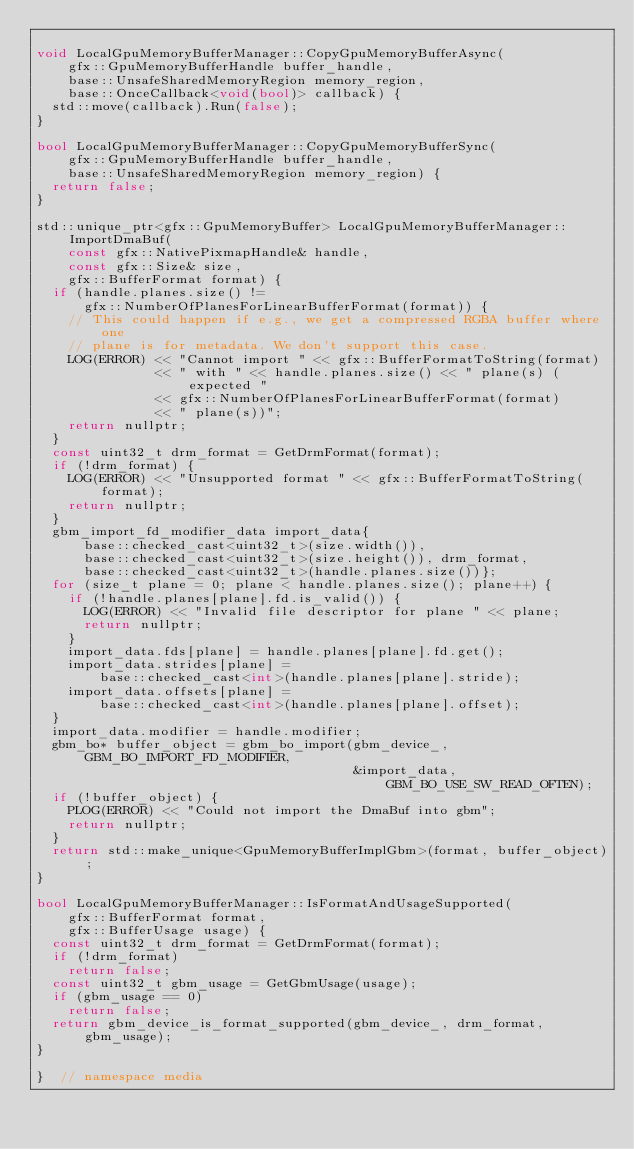<code> <loc_0><loc_0><loc_500><loc_500><_C++_>
void LocalGpuMemoryBufferManager::CopyGpuMemoryBufferAsync(
    gfx::GpuMemoryBufferHandle buffer_handle,
    base::UnsafeSharedMemoryRegion memory_region,
    base::OnceCallback<void(bool)> callback) {
  std::move(callback).Run(false);
}

bool LocalGpuMemoryBufferManager::CopyGpuMemoryBufferSync(
    gfx::GpuMemoryBufferHandle buffer_handle,
    base::UnsafeSharedMemoryRegion memory_region) {
  return false;
}

std::unique_ptr<gfx::GpuMemoryBuffer> LocalGpuMemoryBufferManager::ImportDmaBuf(
    const gfx::NativePixmapHandle& handle,
    const gfx::Size& size,
    gfx::BufferFormat format) {
  if (handle.planes.size() !=
      gfx::NumberOfPlanesForLinearBufferFormat(format)) {
    // This could happen if e.g., we get a compressed RGBA buffer where one
    // plane is for metadata. We don't support this case.
    LOG(ERROR) << "Cannot import " << gfx::BufferFormatToString(format)
               << " with " << handle.planes.size() << " plane(s) (expected "
               << gfx::NumberOfPlanesForLinearBufferFormat(format)
               << " plane(s))";
    return nullptr;
  }
  const uint32_t drm_format = GetDrmFormat(format);
  if (!drm_format) {
    LOG(ERROR) << "Unsupported format " << gfx::BufferFormatToString(format);
    return nullptr;
  }
  gbm_import_fd_modifier_data import_data{
      base::checked_cast<uint32_t>(size.width()),
      base::checked_cast<uint32_t>(size.height()), drm_format,
      base::checked_cast<uint32_t>(handle.planes.size())};
  for (size_t plane = 0; plane < handle.planes.size(); plane++) {
    if (!handle.planes[plane].fd.is_valid()) {
      LOG(ERROR) << "Invalid file descriptor for plane " << plane;
      return nullptr;
    }
    import_data.fds[plane] = handle.planes[plane].fd.get();
    import_data.strides[plane] =
        base::checked_cast<int>(handle.planes[plane].stride);
    import_data.offsets[plane] =
        base::checked_cast<int>(handle.planes[plane].offset);
  }
  import_data.modifier = handle.modifier;
  gbm_bo* buffer_object = gbm_bo_import(gbm_device_, GBM_BO_IMPORT_FD_MODIFIER,
                                        &import_data, GBM_BO_USE_SW_READ_OFTEN);
  if (!buffer_object) {
    PLOG(ERROR) << "Could not import the DmaBuf into gbm";
    return nullptr;
  }
  return std::make_unique<GpuMemoryBufferImplGbm>(format, buffer_object);
}

bool LocalGpuMemoryBufferManager::IsFormatAndUsageSupported(
    gfx::BufferFormat format,
    gfx::BufferUsage usage) {
  const uint32_t drm_format = GetDrmFormat(format);
  if (!drm_format)
    return false;
  const uint32_t gbm_usage = GetGbmUsage(usage);
  if (gbm_usage == 0)
    return false;
  return gbm_device_is_format_supported(gbm_device_, drm_format, gbm_usage);
}

}  // namespace media
</code> 